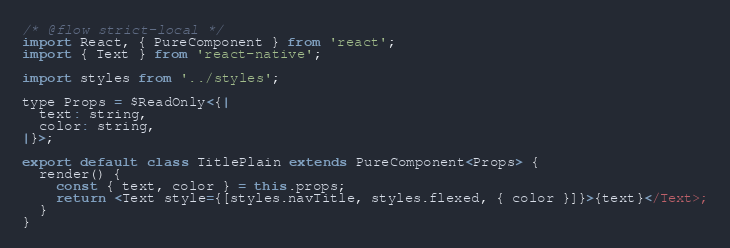Convert code to text. <code><loc_0><loc_0><loc_500><loc_500><_JavaScript_>/* @flow strict-local */
import React, { PureComponent } from 'react';
import { Text } from 'react-native';

import styles from '../styles';

type Props = $ReadOnly<{|
  text: string,
  color: string,
|}>;

export default class TitlePlain extends PureComponent<Props> {
  render() {
    const { text, color } = this.props;
    return <Text style={[styles.navTitle, styles.flexed, { color }]}>{text}</Text>;
  }
}
</code> 